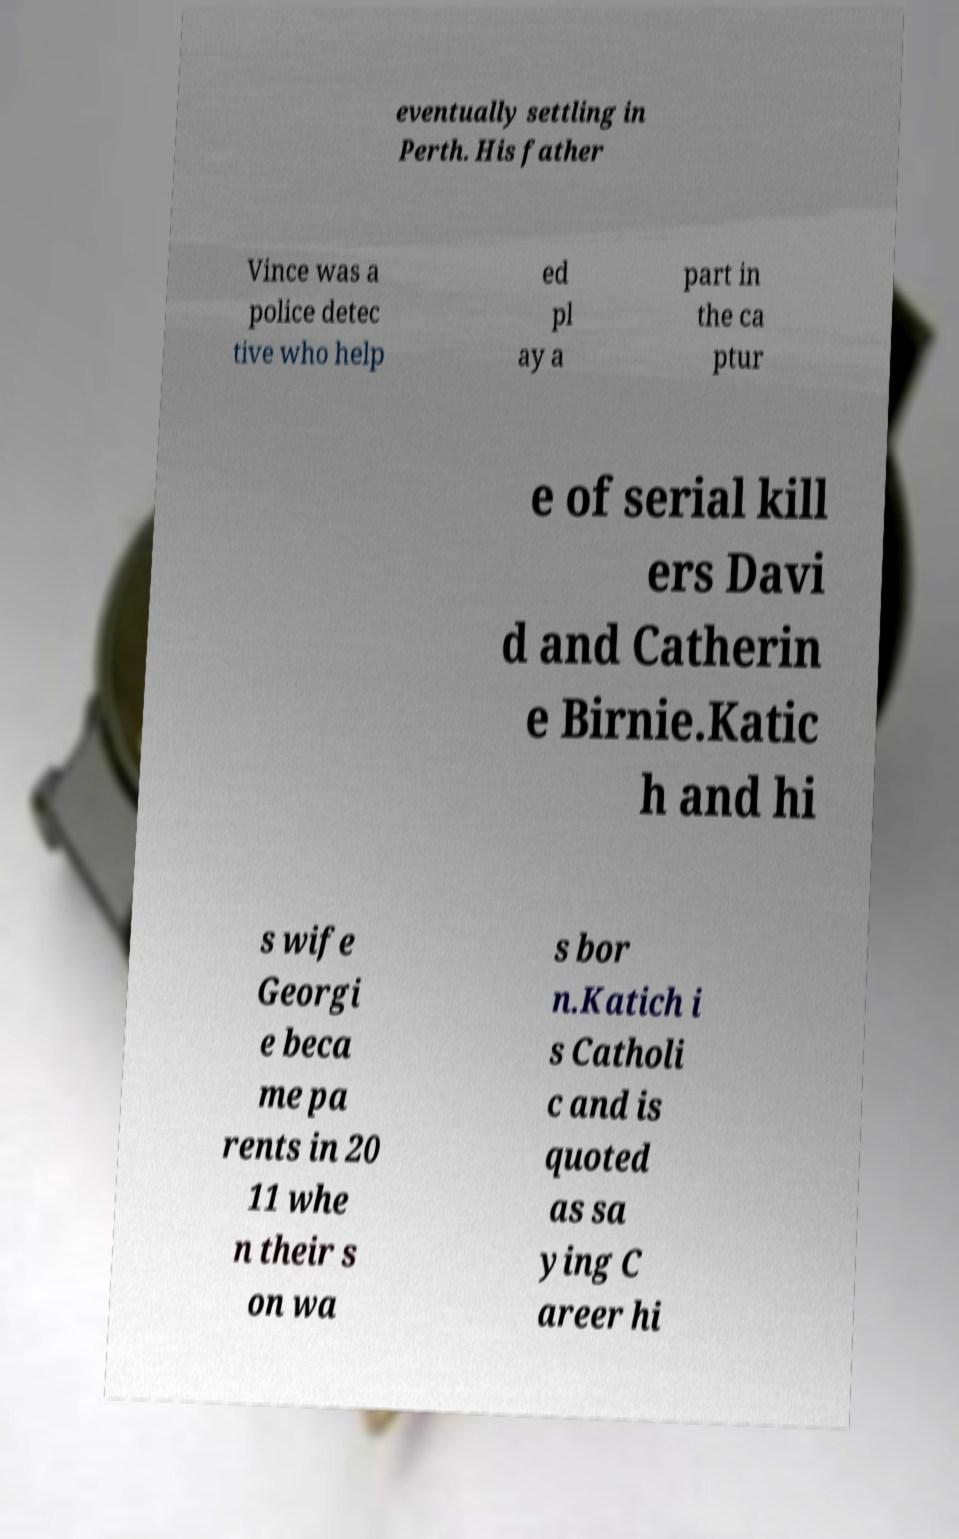Can you read and provide the text displayed in the image?This photo seems to have some interesting text. Can you extract and type it out for me? eventually settling in Perth. His father Vince was a police detec tive who help ed pl ay a part in the ca ptur e of serial kill ers Davi d and Catherin e Birnie.Katic h and hi s wife Georgi e beca me pa rents in 20 11 whe n their s on wa s bor n.Katich i s Catholi c and is quoted as sa ying C areer hi 